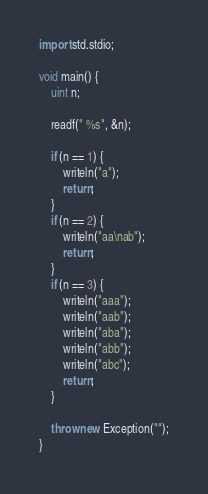<code> <loc_0><loc_0><loc_500><loc_500><_D_>import std.stdio;

void main() {
	uint n;

	readf(" %s", &n);

	if (n == 1) {
		writeln("a");
		return;
	}
	if (n == 2) {
		writeln("aa\nab");
		return;
	}
	if (n == 3) {
		writeln("aaa");
		writeln("aab");
		writeln("aba");
		writeln("abb");
		writeln("abc");
		return;
	}
	
	throw new Exception("");
}
</code> 